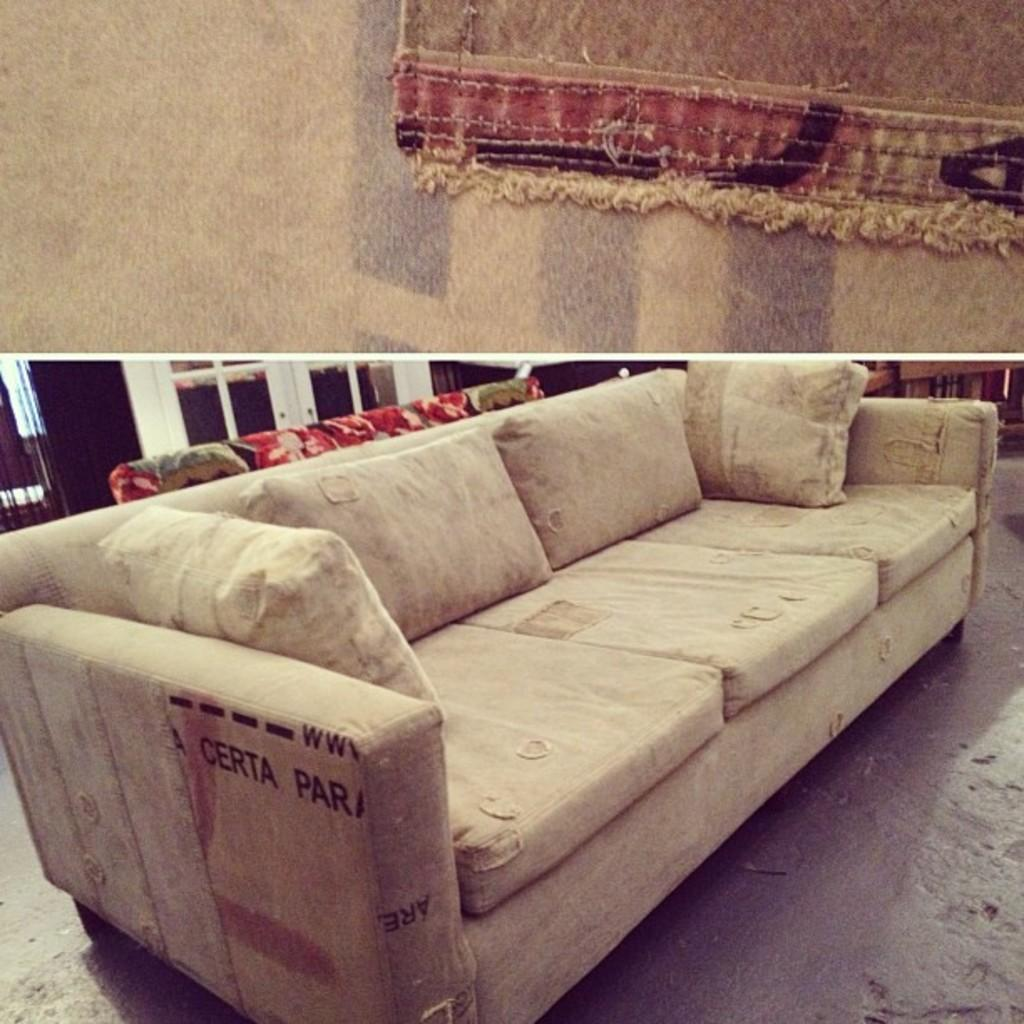What type of structure is present in the image? There is a wall in the image. What is placed on the floor in the image? There is a mat in the image. What type of furniture is in the image? There is a sofa in the image. What is placed on the sofa? There are pillows on the sofa. What type of pen can be seen on the wall in the image? There is no pen present on the wall in the image. How many yams are placed on the sofa in the image? There are no yams present on the sofa in the image. 